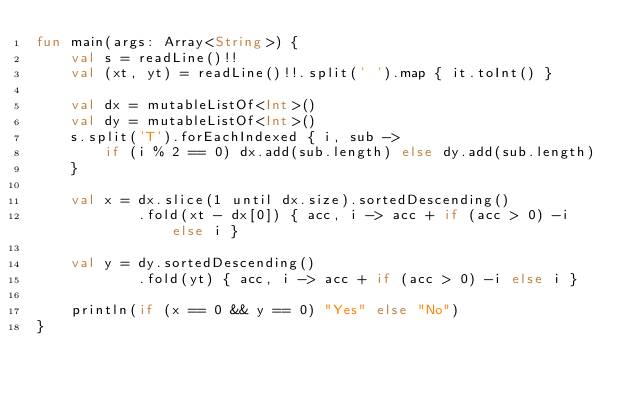<code> <loc_0><loc_0><loc_500><loc_500><_Kotlin_>fun main(args: Array<String>) {
    val s = readLine()!!
    val (xt, yt) = readLine()!!.split(' ').map { it.toInt() }

    val dx = mutableListOf<Int>()
    val dy = mutableListOf<Int>()
    s.split('T').forEachIndexed { i, sub ->
        if (i % 2 == 0) dx.add(sub.length) else dy.add(sub.length)
    }

    val x = dx.slice(1 until dx.size).sortedDescending()
            .fold(xt - dx[0]) { acc, i -> acc + if (acc > 0) -i else i }

    val y = dy.sortedDescending()
            .fold(yt) { acc, i -> acc + if (acc > 0) -i else i }

    println(if (x == 0 && y == 0) "Yes" else "No")
}
</code> 